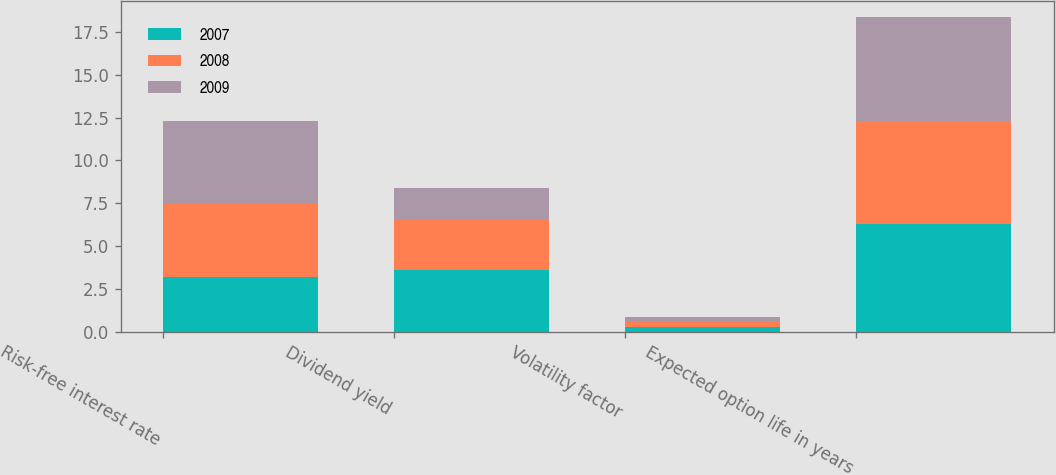<chart> <loc_0><loc_0><loc_500><loc_500><stacked_bar_chart><ecel><fcel>Risk-free interest rate<fcel>Dividend yield<fcel>Volatility factor<fcel>Expected option life in years<nl><fcel>2007<fcel>3.2<fcel>3.6<fcel>0.28<fcel>6.3<nl><fcel>2008<fcel>4.3<fcel>2.9<fcel>0.26<fcel>6<nl><fcel>2009<fcel>4.8<fcel>1.9<fcel>0.3<fcel>6.1<nl></chart> 